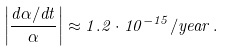<formula> <loc_0><loc_0><loc_500><loc_500>\left | \frac { d \alpha / d t } { \alpha } \right | \approx 1 . 2 \cdot 1 0 ^ { - 1 5 } / y e a r \, .</formula> 